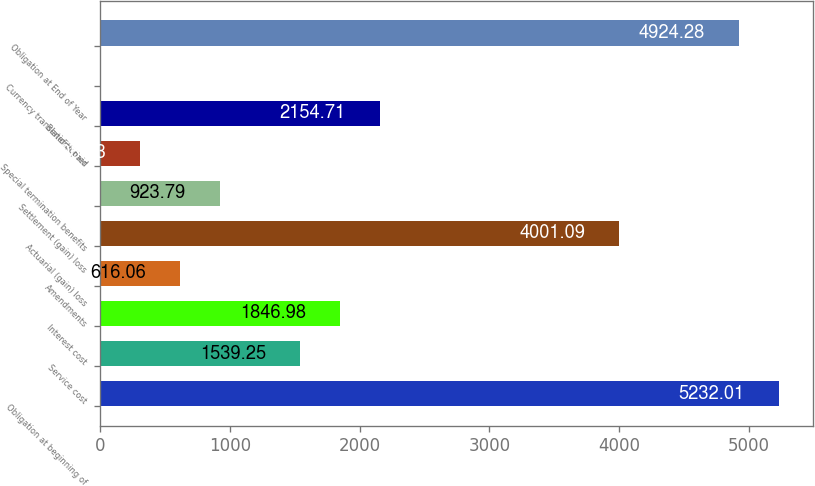<chart> <loc_0><loc_0><loc_500><loc_500><bar_chart><fcel>Obligation at beginning of<fcel>Service cost<fcel>Interest cost<fcel>Amendments<fcel>Actuarial (gain) loss<fcel>Settlement (gain) loss<fcel>Special termination benefits<fcel>Benefits paid<fcel>Currency translation/other<fcel>Obligation at End of Year<nl><fcel>5232.01<fcel>1539.25<fcel>1846.98<fcel>616.06<fcel>4001.09<fcel>923.79<fcel>308.33<fcel>2154.71<fcel>0.6<fcel>4924.28<nl></chart> 